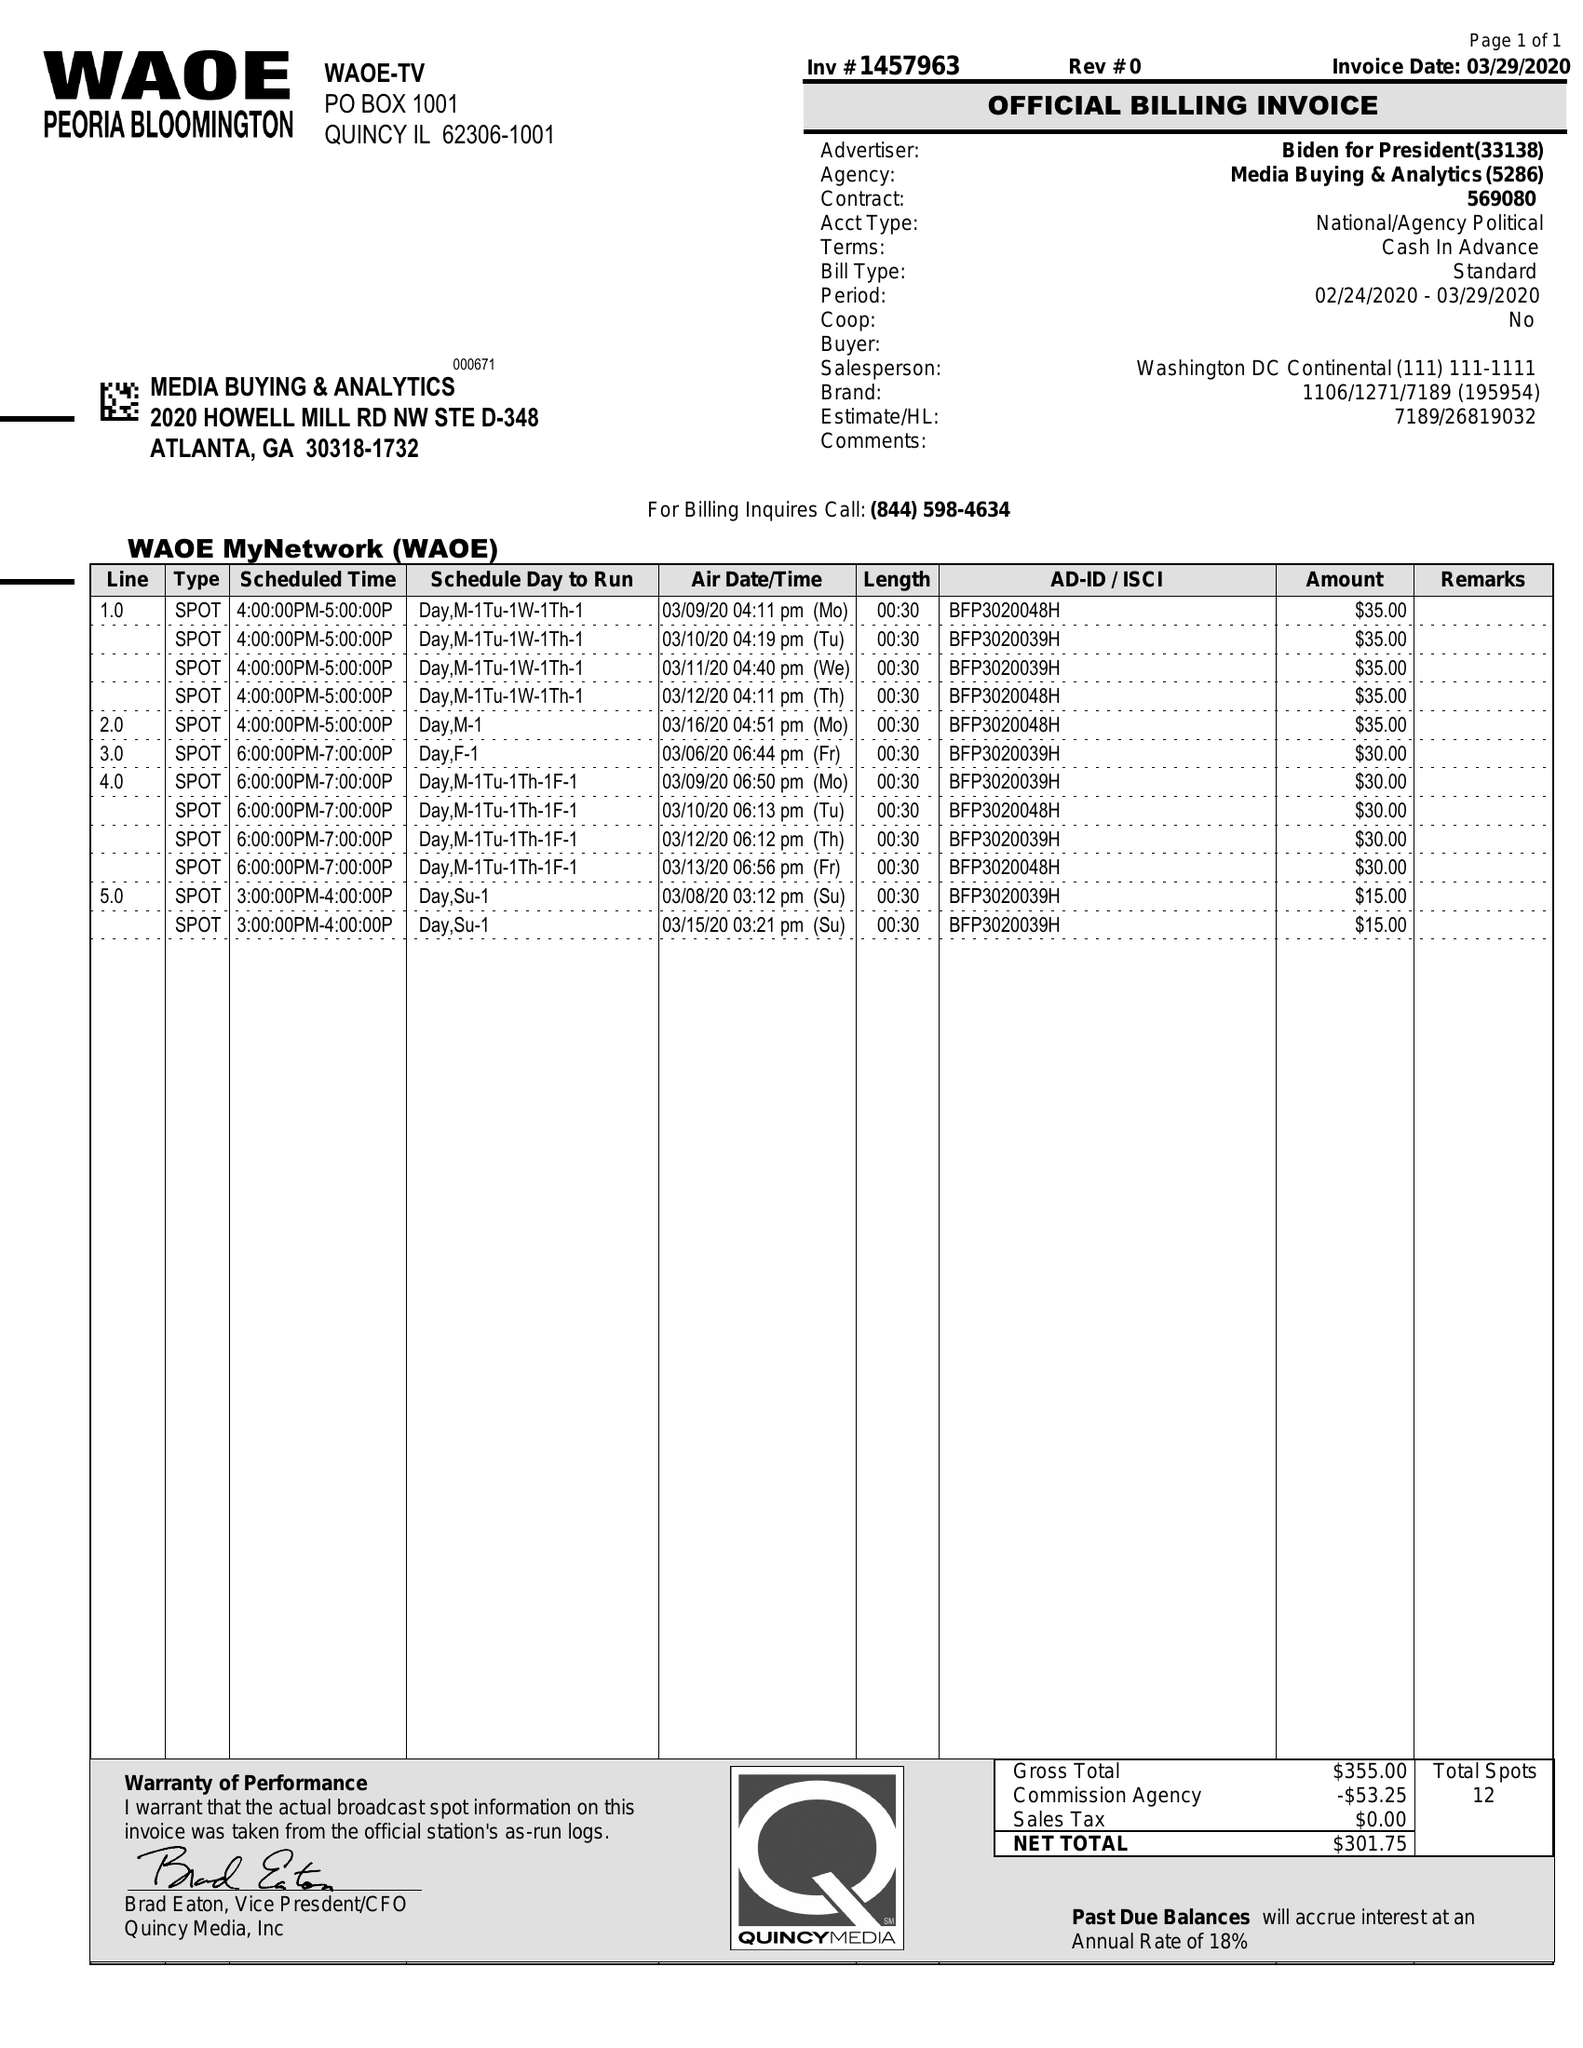What is the value for the flight_from?
Answer the question using a single word or phrase. 03/06/20 